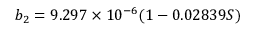Convert formula to latex. <formula><loc_0><loc_0><loc_500><loc_500>b _ { 2 } = 9 . 2 9 7 \times 1 0 ^ { - 6 } ( 1 - 0 . 0 2 8 3 9 S )</formula> 